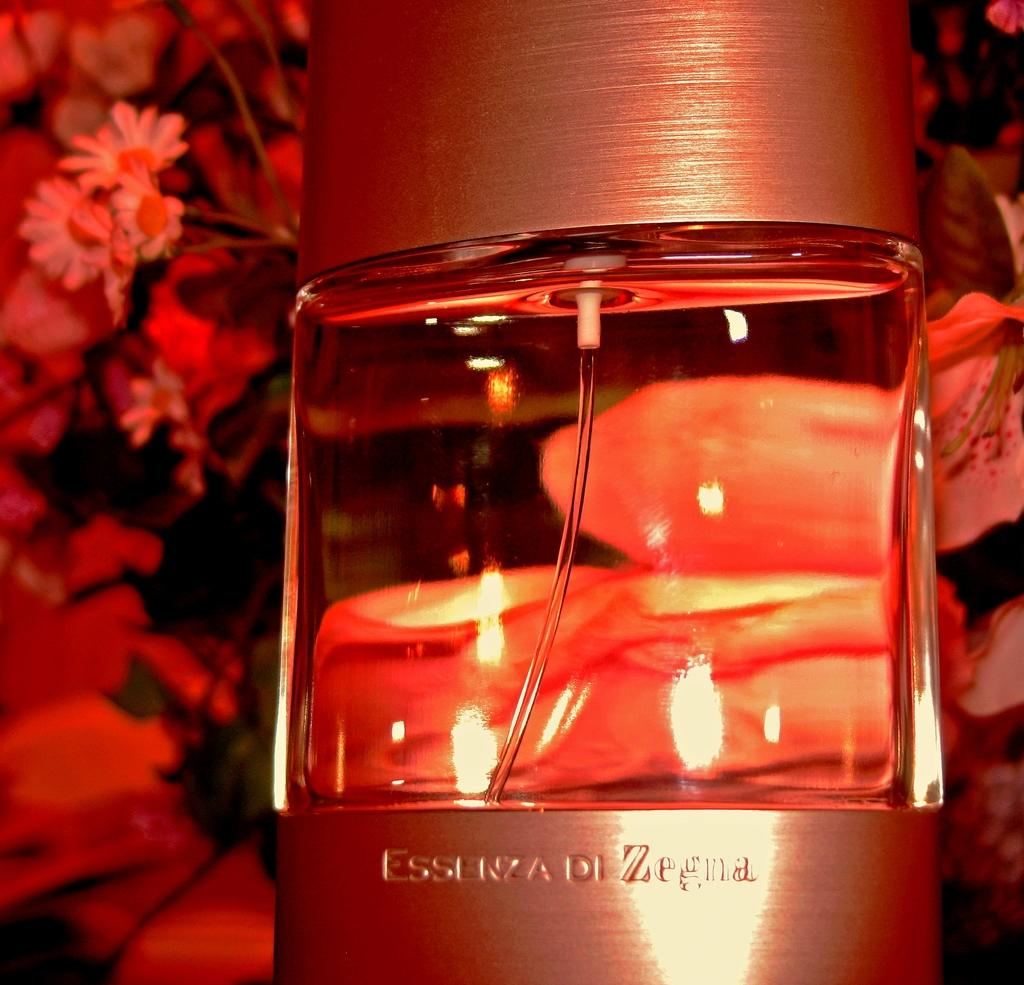<image>
Write a terse but informative summary of the picture. A perfume bottle in an orange light that read Essenza di Zegna. 